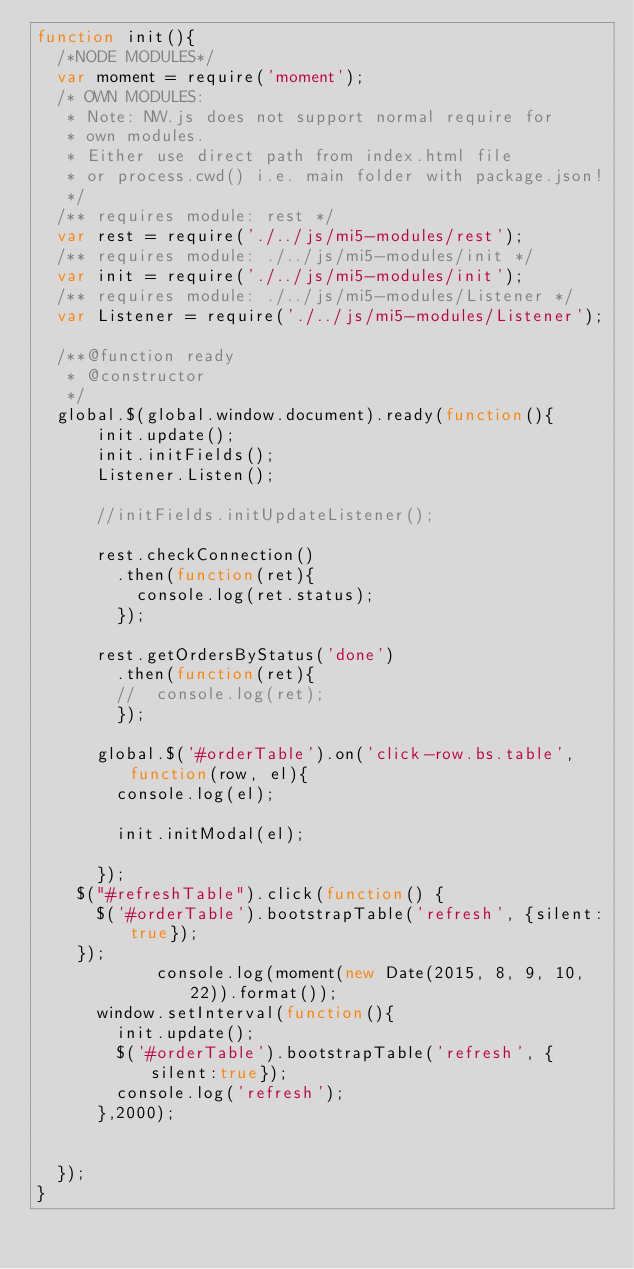Convert code to text. <code><loc_0><loc_0><loc_500><loc_500><_JavaScript_>function init(){
	/*NODE MODULES*/
	var moment = require('moment');	
	/* OWN MODULES:
	 * Note: NW.js does not support normal require for
	 * own modules.
	 * Either use direct path from index.html file 
	 * or process.cwd() i.e. main folder with package.json! 
	 */
	/** requires module: rest */
	var rest = require('./../js/mi5-modules/rest');
	/** requires module: ./../js/mi5-modules/init */
	var init = require('./../js/mi5-modules/init');
	/** requires module: ./../js/mi5-modules/Listener */
	var Listener = require('./../js/mi5-modules/Listener');

	/**@function ready
	 * @constructor
	 */
	global.$(global.window.document).ready(function(){
			init.update();
			init.initFields();
			Listener.Listen();

			//initFields.initUpdateListener(); 
		
			rest.checkConnection()
				.then(function(ret){
					console.log(ret.status);
				});
			
			rest.getOrdersByStatus('done')
				.then(function(ret){
				//	console.log(ret);
				});
				
			global.$('#orderTable').on('click-row.bs.table', function(row, el){
				console.log(el);
				
				init.initModal(el);

			});
		$("#refreshTable").click(function() {
			$('#orderTable').bootstrapTable('refresh', {silent:true});
		});
            console.log(moment(new Date(2015, 8, 9, 10, 22)).format());
			window.setInterval(function(){
				init.update();
				$('#orderTable').bootstrapTable('refresh', {silent:true});
				console.log('refresh');
			},2000);
			

	});
}</code> 